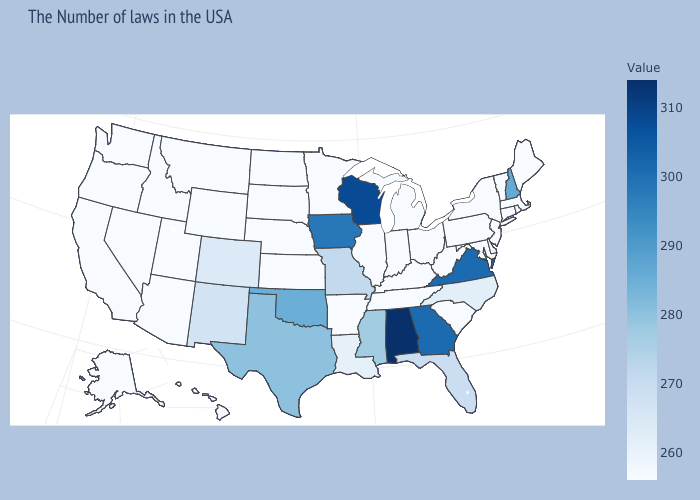Is the legend a continuous bar?
Quick response, please. Yes. Does Connecticut have a higher value than Florida?
Give a very brief answer. No. Is the legend a continuous bar?
Write a very short answer. Yes. Which states have the lowest value in the USA?
Be succinct. Maine, Massachusetts, Rhode Island, Vermont, Connecticut, New York, New Jersey, Delaware, Maryland, Pennsylvania, South Carolina, West Virginia, Ohio, Michigan, Kentucky, Indiana, Tennessee, Illinois, Arkansas, Minnesota, Kansas, Nebraska, South Dakota, North Dakota, Wyoming, Utah, Montana, Arizona, Idaho, Nevada, California, Washington, Oregon, Alaska, Hawaii. Which states have the lowest value in the USA?
Quick response, please. Maine, Massachusetts, Rhode Island, Vermont, Connecticut, New York, New Jersey, Delaware, Maryland, Pennsylvania, South Carolina, West Virginia, Ohio, Michigan, Kentucky, Indiana, Tennessee, Illinois, Arkansas, Minnesota, Kansas, Nebraska, South Dakota, North Dakota, Wyoming, Utah, Montana, Arizona, Idaho, Nevada, California, Washington, Oregon, Alaska, Hawaii. Among the states that border Virginia , which have the lowest value?
Answer briefly. Maryland, West Virginia, Kentucky, Tennessee. Among the states that border Massachusetts , does New Hampshire have the lowest value?
Keep it brief. No. Among the states that border Delaware , which have the lowest value?
Answer briefly. New Jersey, Maryland, Pennsylvania. 